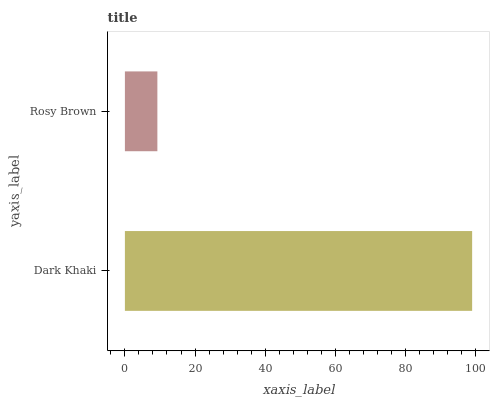Is Rosy Brown the minimum?
Answer yes or no. Yes. Is Dark Khaki the maximum?
Answer yes or no. Yes. Is Rosy Brown the maximum?
Answer yes or no. No. Is Dark Khaki greater than Rosy Brown?
Answer yes or no. Yes. Is Rosy Brown less than Dark Khaki?
Answer yes or no. Yes. Is Rosy Brown greater than Dark Khaki?
Answer yes or no. No. Is Dark Khaki less than Rosy Brown?
Answer yes or no. No. Is Dark Khaki the high median?
Answer yes or no. Yes. Is Rosy Brown the low median?
Answer yes or no. Yes. Is Rosy Brown the high median?
Answer yes or no. No. Is Dark Khaki the low median?
Answer yes or no. No. 